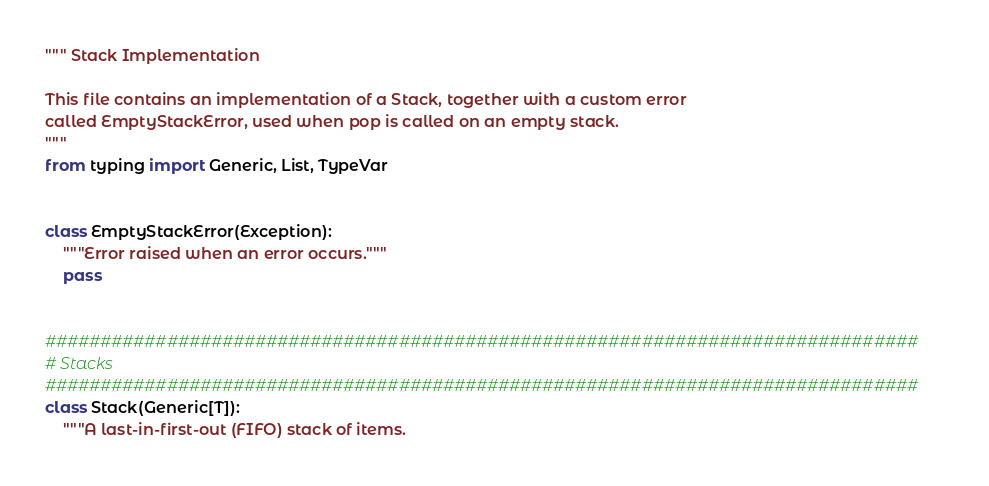<code> <loc_0><loc_0><loc_500><loc_500><_Python_>""" Stack Implementation

This file contains an implementation of a Stack, together with a custom error
called EmptyStackError, used when pop is called on an empty stack.
"""
from typing import Generic, List, TypeVar


class EmptyStackError(Exception):
    """Error raised when an error occurs."""
    pass


###############################################################################
# Stacks
###############################################################################
class Stack(Generic[T]):
    """A last-in-first-out (FIFO) stack of items.
</code> 